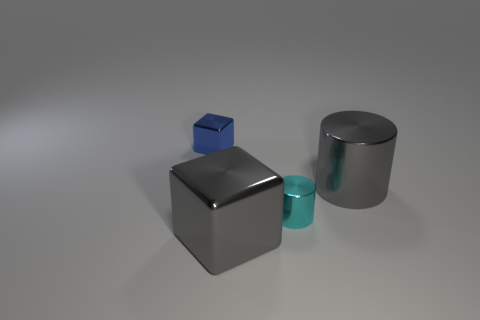What number of small things are either green shiny cylinders or shiny cylinders?
Give a very brief answer. 1. Are there any large blocks of the same color as the small shiny cylinder?
Ensure brevity in your answer.  No. There is a gray thing that is the same size as the gray cube; what shape is it?
Provide a short and direct response. Cylinder. There is a cube that is behind the gray metal block; is it the same color as the large metal cube?
Your response must be concise. No. What number of things are either gray things that are on the right side of the blue cube or small metallic things?
Keep it short and to the point. 4. Are there more gray objects that are on the left side of the small blue thing than blue blocks in front of the cyan metal object?
Ensure brevity in your answer.  No. Is the tiny blue block made of the same material as the small cylinder?
Give a very brief answer. Yes. There is a metallic thing that is both left of the small cylinder and on the right side of the small blue metal object; what shape is it?
Provide a short and direct response. Cube. What is the shape of the small object that is made of the same material as the small blue cube?
Provide a short and direct response. Cylinder. Is there a brown metal cylinder?
Your response must be concise. No. 